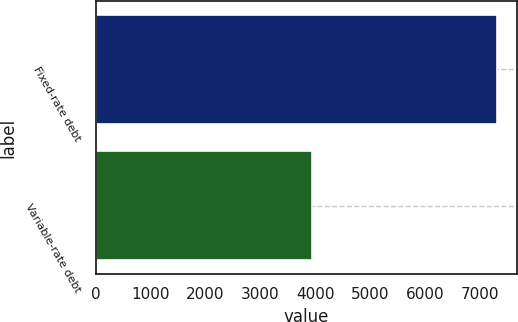Convert chart to OTSL. <chart><loc_0><loc_0><loc_500><loc_500><bar_chart><fcel>Fixed-rate debt<fcel>Variable-rate debt<nl><fcel>7315<fcel>3934<nl></chart> 